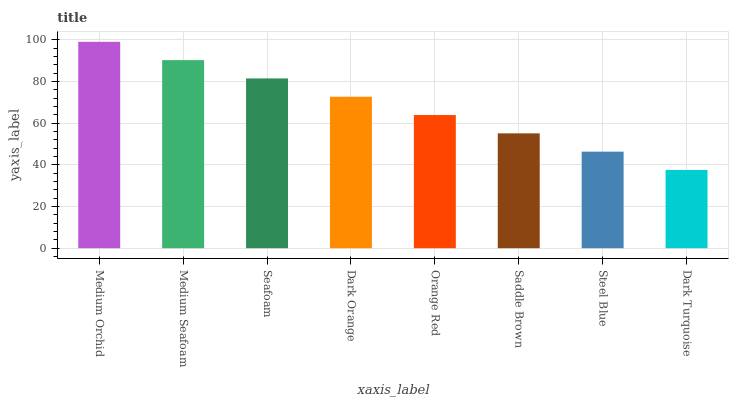Is Medium Seafoam the minimum?
Answer yes or no. No. Is Medium Seafoam the maximum?
Answer yes or no. No. Is Medium Orchid greater than Medium Seafoam?
Answer yes or no. Yes. Is Medium Seafoam less than Medium Orchid?
Answer yes or no. Yes. Is Medium Seafoam greater than Medium Orchid?
Answer yes or no. No. Is Medium Orchid less than Medium Seafoam?
Answer yes or no. No. Is Dark Orange the high median?
Answer yes or no. Yes. Is Orange Red the low median?
Answer yes or no. Yes. Is Steel Blue the high median?
Answer yes or no. No. Is Dark Turquoise the low median?
Answer yes or no. No. 